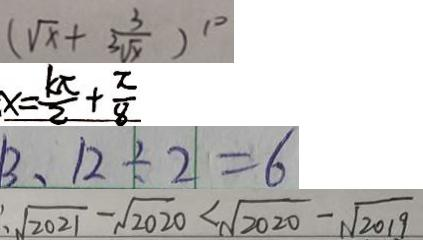<formula> <loc_0><loc_0><loc_500><loc_500>( \sqrt { x } + \frac { 3 } { \sqrt [ 3 ] { x } } ) ^ { 1 0 } 
 x = \frac { k \pi } { 2 } + \frac { \pi } { 8 } 
 1 3 、 1 2 \div 2 = 6 
 \sqrt { 2 0 2 1 } - \sqrt { 2 0 2 0 } < \sqrt { 2 0 2 0 } - \sqrt { 2 0 1 9 }</formula> 